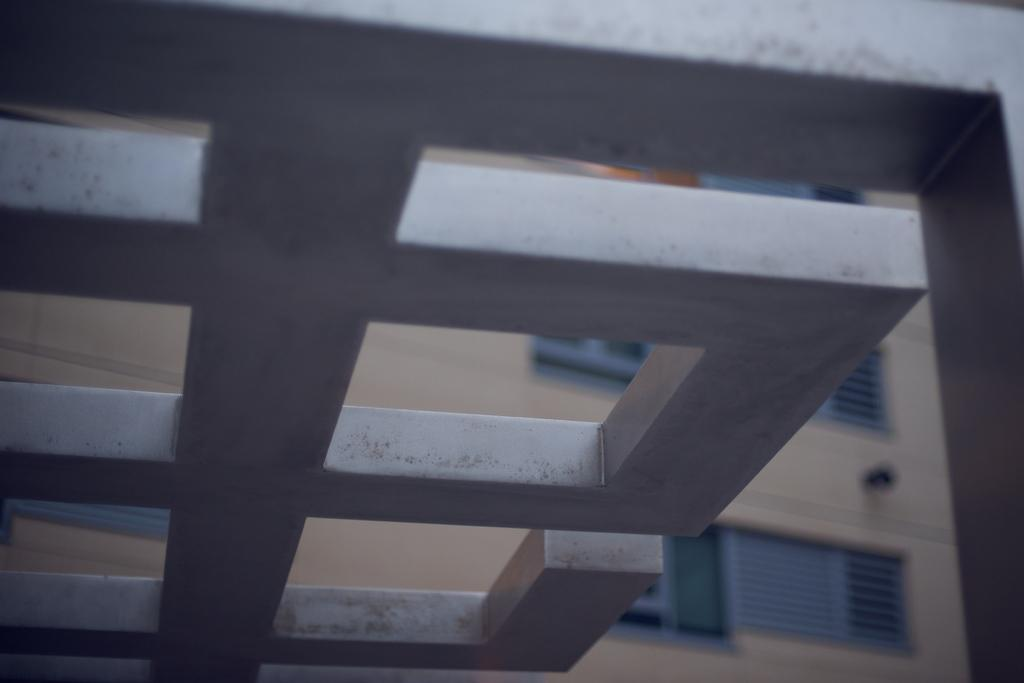What is present on top of the structure in the image? There is a roof in the image. What type of structure can be seen in the background of the image? There is a building in the background of the image. What feature of the building is visible in the image? There is a window visible in the background of the image. What type of agreement is being signed in the image? There is no indication of an agreement or any signing activity in the image. 